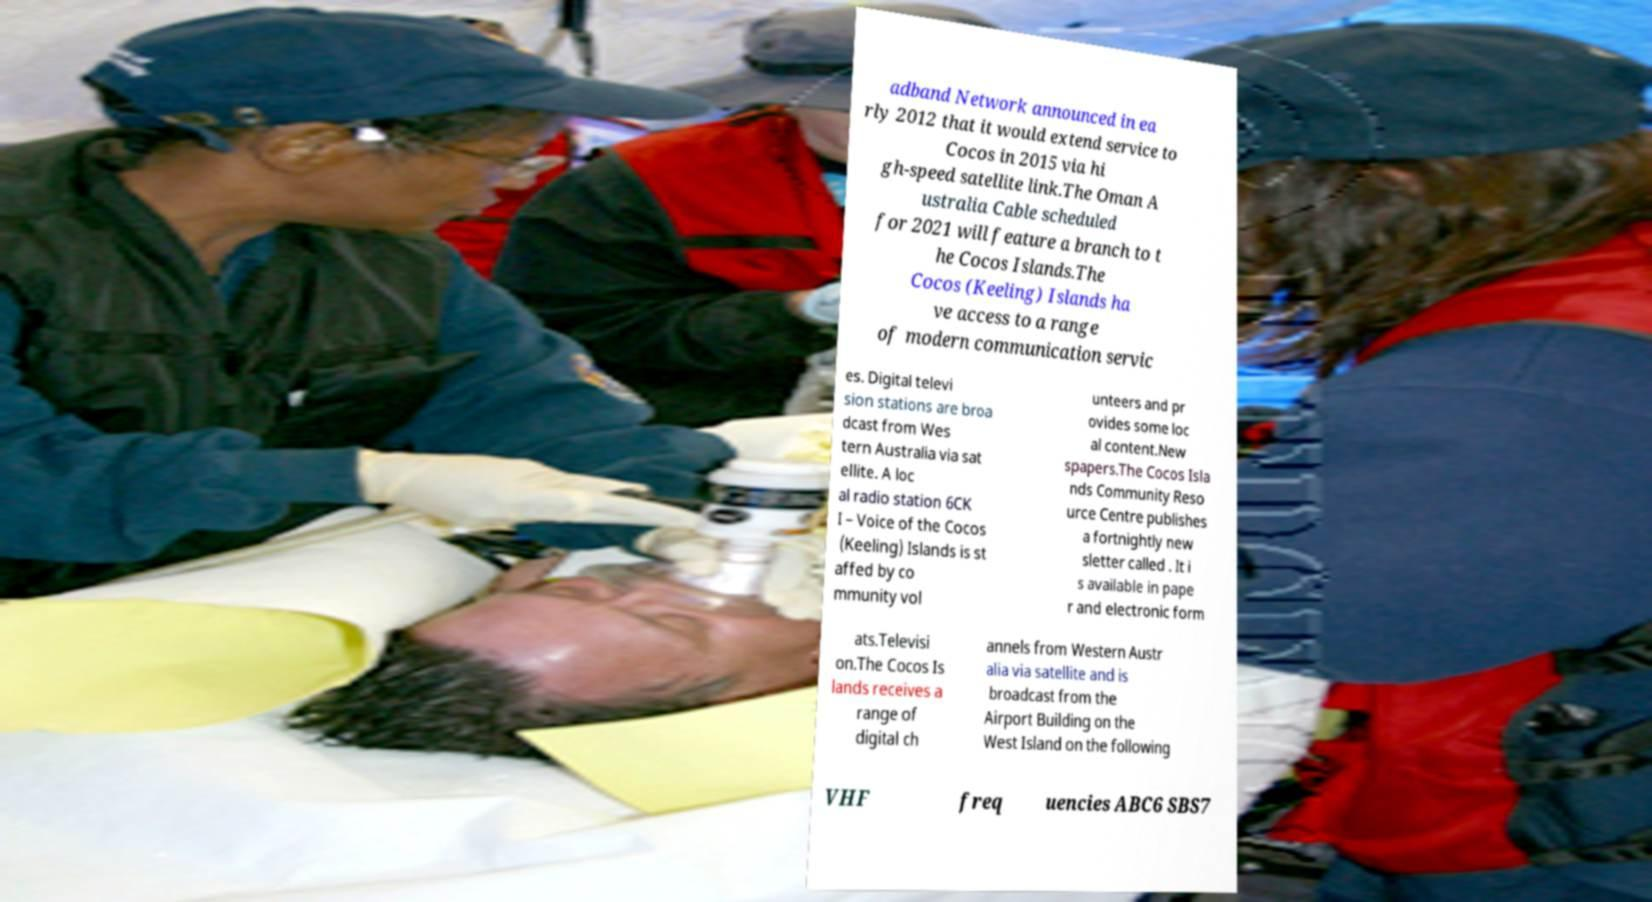Can you read and provide the text displayed in the image?This photo seems to have some interesting text. Can you extract and type it out for me? adband Network announced in ea rly 2012 that it would extend service to Cocos in 2015 via hi gh-speed satellite link.The Oman A ustralia Cable scheduled for 2021 will feature a branch to t he Cocos Islands.The Cocos (Keeling) Islands ha ve access to a range of modern communication servic es. Digital televi sion stations are broa dcast from Wes tern Australia via sat ellite. A loc al radio station 6CK I – Voice of the Cocos (Keeling) Islands is st affed by co mmunity vol unteers and pr ovides some loc al content.New spapers.The Cocos Isla nds Community Reso urce Centre publishes a fortnightly new sletter called . It i s available in pape r and electronic form ats.Televisi on.The Cocos Is lands receives a range of digital ch annels from Western Austr alia via satellite and is broadcast from the Airport Building on the West Island on the following VHF freq uencies ABC6 SBS7 